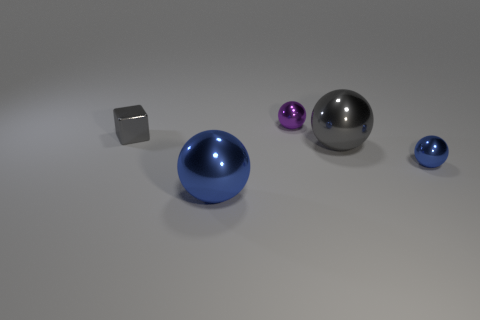What is the size of the metal ball that is the same color as the tiny metal block?
Offer a very short reply. Large. What number of other objects are the same shape as the small blue thing?
Your response must be concise. 3. There is a big gray object; does it have the same shape as the tiny metal object behind the tiny gray metal object?
Keep it short and to the point. Yes. What number of small blue balls are behind the tiny blue shiny ball?
Offer a very short reply. 0. Is there anything else that has the same material as the big blue ball?
Give a very brief answer. Yes. Does the gray thing that is to the right of the tiny cube have the same shape as the tiny blue object?
Offer a very short reply. Yes. The small metal ball that is behind the large gray thing is what color?
Offer a terse response. Purple. What is the shape of the big gray thing that is made of the same material as the tiny purple thing?
Provide a succinct answer. Sphere. Is the number of purple objects that are to the right of the block greater than the number of small objects that are in front of the small blue object?
Give a very brief answer. Yes. How many shiny blocks have the same size as the purple metallic thing?
Provide a short and direct response. 1. 